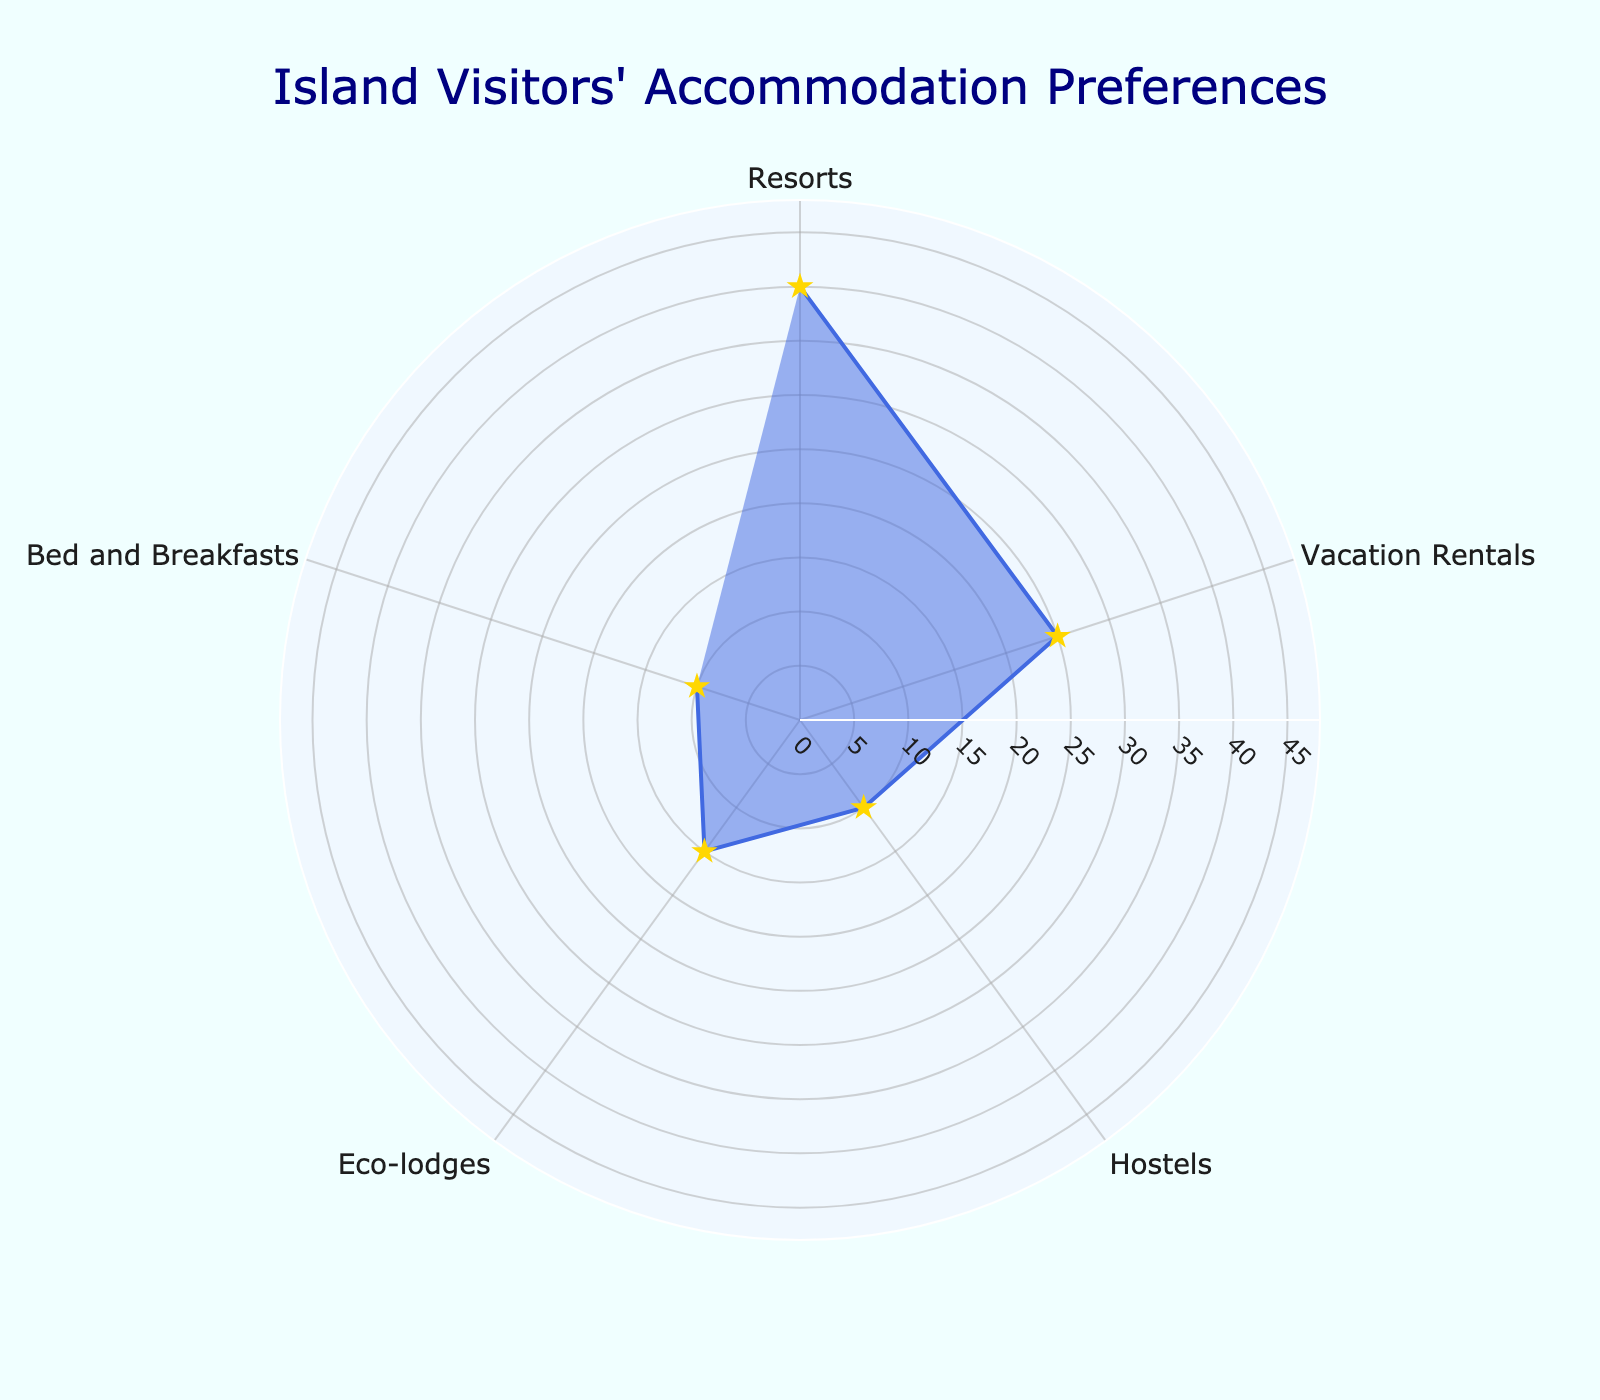What's the title of the figure? The title is located at the top of the figure and provides a summary of the chart's purpose.
Answer: Island Visitors' Accommodation Preferences Which accommodation type is most preferred by island visitors? The highest point on the radar chart, reaching out the furthest, corresponds to the most preferred accommodation type.
Answer: Resorts What are the two least preferred accommodation types by island visitors? The two smallest values on the radar chart indicate the least preferred types.
Answer: Hostels and Bed and Breakfasts What is the combined percentage preference for Hostels and Eco-lodges? Sum the percentage preferences indicated by the data points for Hostels and Eco-lodges.
Answer: 25% How much more preferred are Resorts compared to Vacation Rentals? Subtract the percentage of Vacation Rentals from the percentage of Resorts to find the difference.
Answer: 15% Arrange the accommodation types in descending order of preference. List all accommodation types and their corresponding percentages, then sort them from highest to lowest.
Answer: Resorts, Vacation Rentals, Eco-lodges, Hostels, Bed and Breakfasts What is the average percentage preference across all accommodation types? Sum all the percentages and divide by the number of accommodation types.
Answer: 20% Which accommodation types have a preference equal to or above the average? Compare each accommodation type's percentage with the calculated average to determine which are equal to or above.
Answer: Resorts, Vacation Rentals, Eco-lodges What is the total preference percentage for accommodation types preferred by less than 20% of visitors? Add the percentages for all types that are below 20%.
Answer: 35% By how much does the preference for Bed and Breakfasts fall short of Eco-lodges? Subtract the percentage of Bed and Breakfasts from the percentage of Eco-lodges to determine the shortfall.
Answer: 5% 